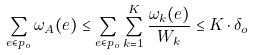<formula> <loc_0><loc_0><loc_500><loc_500>\sum _ { e \in p _ { o } } \omega _ { A } ( e ) \leq \sum _ { e \in p _ { o } } \sum _ { k = 1 } ^ { K } \frac { \omega _ { k } ( e ) } { W _ { k } } \leq K \cdot \delta _ { o }</formula> 